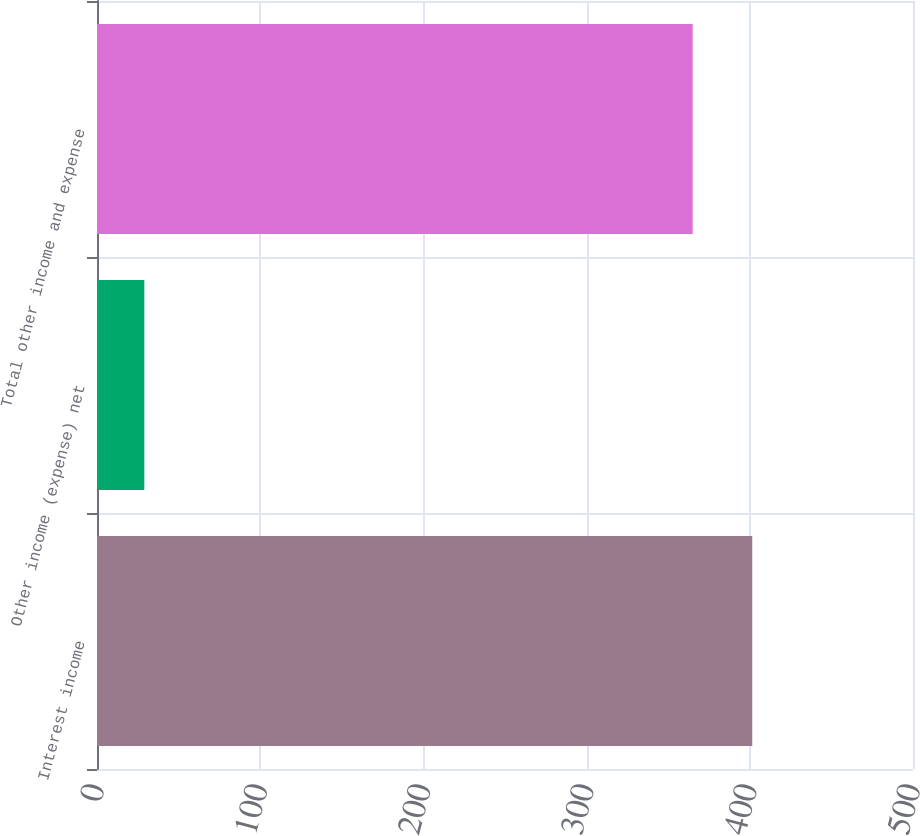Convert chart. <chart><loc_0><loc_0><loc_500><loc_500><bar_chart><fcel>Interest income<fcel>Other income (expense) net<fcel>Total other income and expense<nl><fcel>401.5<fcel>29<fcel>365<nl></chart> 